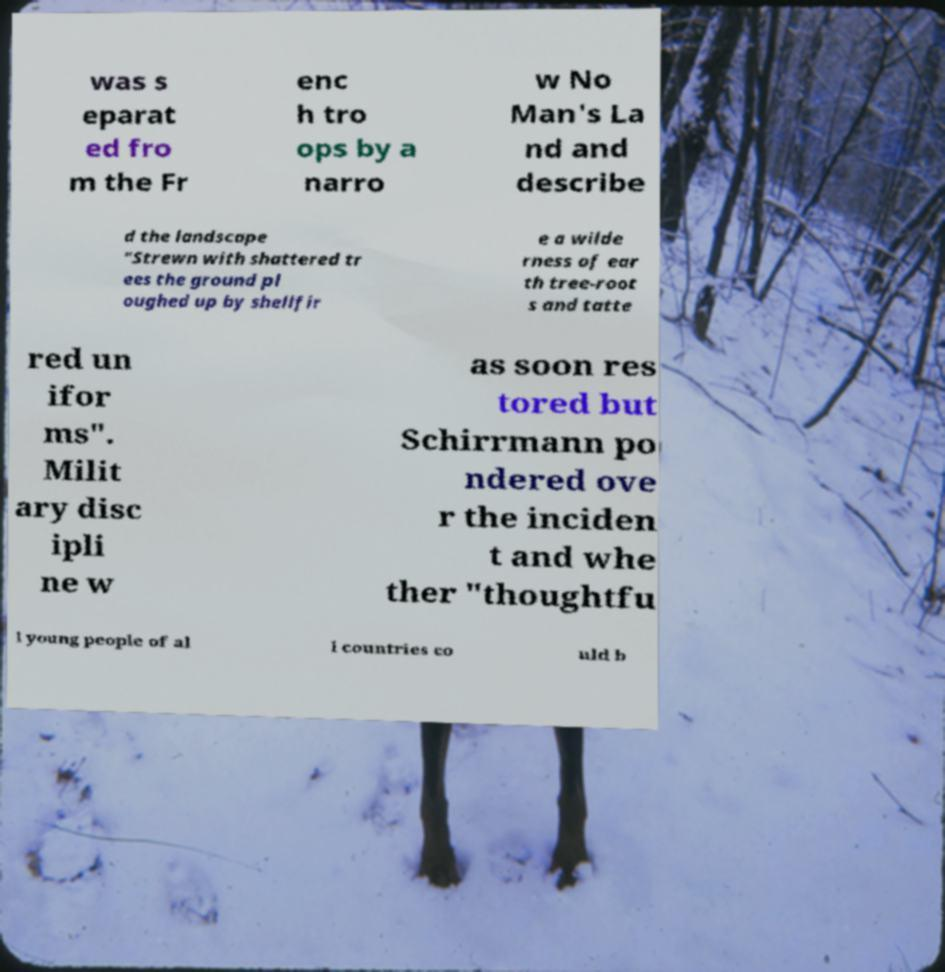Can you read and provide the text displayed in the image?This photo seems to have some interesting text. Can you extract and type it out for me? was s eparat ed fro m the Fr enc h tro ops by a narro w No Man's La nd and describe d the landscape "Strewn with shattered tr ees the ground pl oughed up by shellfir e a wilde rness of ear th tree-root s and tatte red un ifor ms". Milit ary disc ipli ne w as soon res tored but Schirrmann po ndered ove r the inciden t and whe ther "thoughtfu l young people of al l countries co uld b 